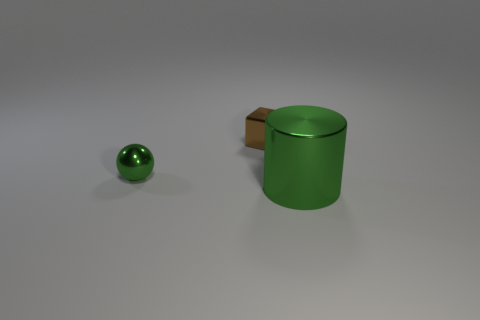There is a shiny object that is the same color as the small shiny ball; what is its shape?
Provide a short and direct response. Cylinder. What is the small block made of?
Give a very brief answer. Metal. Is the sphere made of the same material as the large object?
Your answer should be compact. Yes. How many matte things are either tiny gray cylinders or cylinders?
Your answer should be very brief. 0. There is a green shiny object behind the big green metallic cylinder; what shape is it?
Offer a terse response. Sphere. There is a cube that is made of the same material as the small green ball; what size is it?
Your answer should be compact. Small. There is a metallic thing that is right of the tiny green metallic ball and in front of the small brown metallic block; what is its shape?
Offer a very short reply. Cylinder. There is a small shiny thing that is left of the tiny brown metallic object; does it have the same color as the shiny cylinder?
Give a very brief answer. Yes. Is the shape of the thing behind the tiny green metal sphere the same as the object in front of the sphere?
Your answer should be very brief. No. There is a green thing that is on the right side of the brown block; what size is it?
Make the answer very short. Large. 